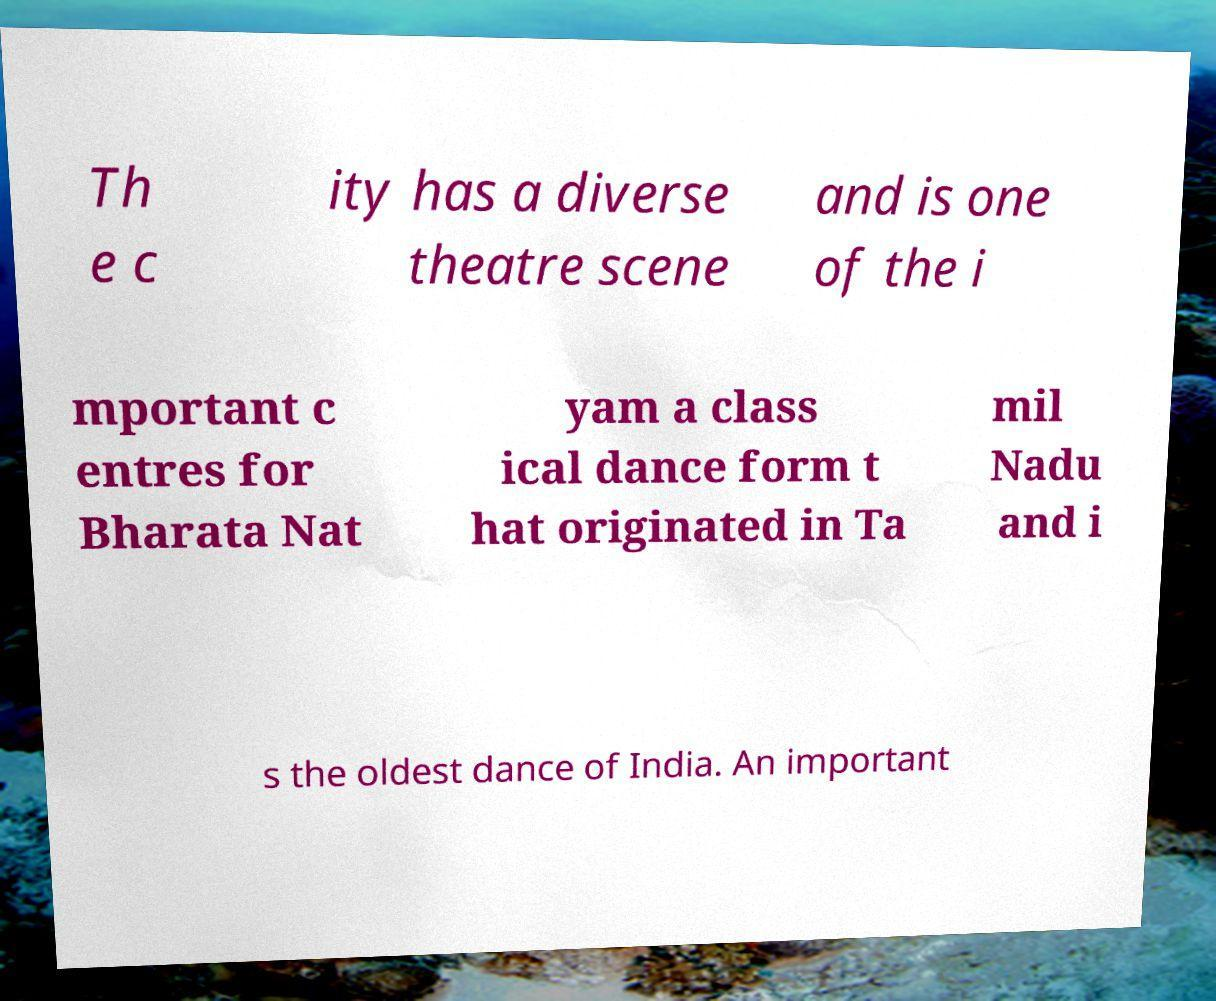Could you extract and type out the text from this image? Th e c ity has a diverse theatre scene and is one of the i mportant c entres for Bharata Nat yam a class ical dance form t hat originated in Ta mil Nadu and i s the oldest dance of India. An important 